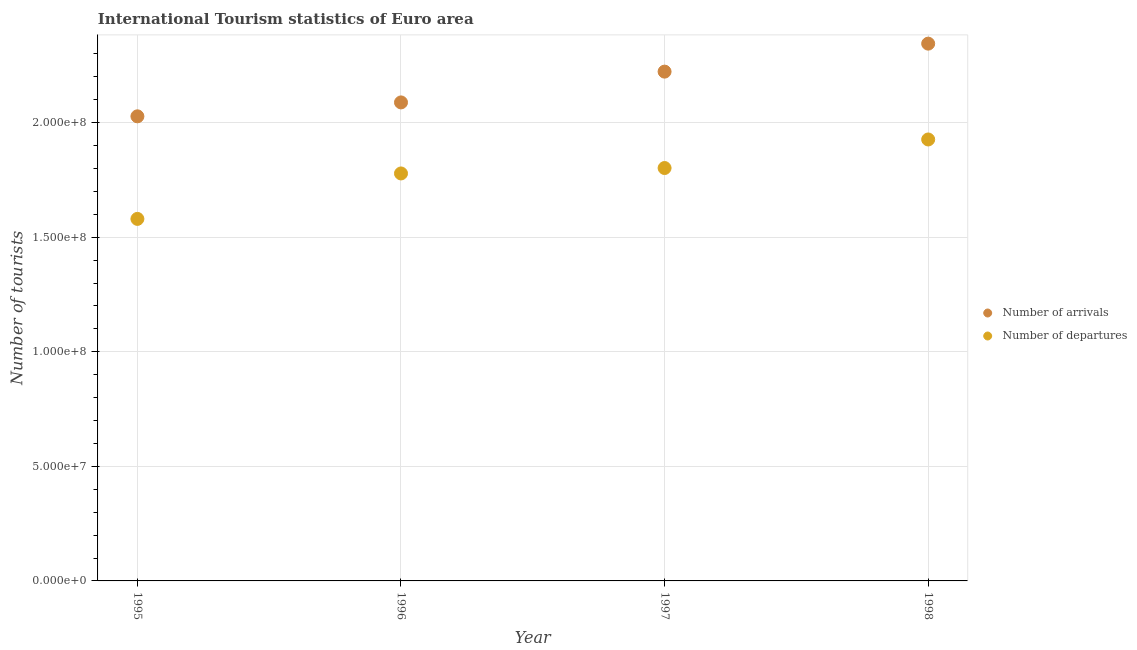How many different coloured dotlines are there?
Provide a succinct answer. 2. Is the number of dotlines equal to the number of legend labels?
Offer a terse response. Yes. What is the number of tourist departures in 1995?
Make the answer very short. 1.58e+08. Across all years, what is the maximum number of tourist departures?
Your answer should be compact. 1.93e+08. Across all years, what is the minimum number of tourist arrivals?
Your answer should be very brief. 2.03e+08. In which year was the number of tourist arrivals minimum?
Provide a succinct answer. 1995. What is the total number of tourist arrivals in the graph?
Ensure brevity in your answer.  8.68e+08. What is the difference between the number of tourist departures in 1995 and that in 1996?
Offer a very short reply. -1.98e+07. What is the difference between the number of tourist departures in 1997 and the number of tourist arrivals in 1995?
Provide a short and direct response. -2.26e+07. What is the average number of tourist arrivals per year?
Your answer should be compact. 2.17e+08. In the year 1995, what is the difference between the number of tourist arrivals and number of tourist departures?
Offer a very short reply. 4.48e+07. What is the ratio of the number of tourist arrivals in 1995 to that in 1997?
Offer a terse response. 0.91. Is the number of tourist departures in 1995 less than that in 1998?
Provide a short and direct response. Yes. Is the difference between the number of tourist arrivals in 1995 and 1998 greater than the difference between the number of tourist departures in 1995 and 1998?
Keep it short and to the point. Yes. What is the difference between the highest and the second highest number of tourist departures?
Provide a short and direct response. 1.25e+07. What is the difference between the highest and the lowest number of tourist departures?
Your answer should be compact. 3.47e+07. In how many years, is the number of tourist arrivals greater than the average number of tourist arrivals taken over all years?
Keep it short and to the point. 2. Does the number of tourist departures monotonically increase over the years?
Offer a terse response. Yes. How many dotlines are there?
Your response must be concise. 2. How many years are there in the graph?
Your response must be concise. 4. What is the difference between two consecutive major ticks on the Y-axis?
Your answer should be very brief. 5.00e+07. Are the values on the major ticks of Y-axis written in scientific E-notation?
Your answer should be very brief. Yes. Does the graph contain grids?
Offer a very short reply. Yes. What is the title of the graph?
Ensure brevity in your answer.  International Tourism statistics of Euro area. What is the label or title of the X-axis?
Your response must be concise. Year. What is the label or title of the Y-axis?
Provide a short and direct response. Number of tourists. What is the Number of tourists of Number of arrivals in 1995?
Offer a very short reply. 2.03e+08. What is the Number of tourists in Number of departures in 1995?
Your answer should be very brief. 1.58e+08. What is the Number of tourists in Number of arrivals in 1996?
Make the answer very short. 2.09e+08. What is the Number of tourists in Number of departures in 1996?
Make the answer very short. 1.78e+08. What is the Number of tourists in Number of arrivals in 1997?
Give a very brief answer. 2.22e+08. What is the Number of tourists in Number of departures in 1997?
Keep it short and to the point. 1.80e+08. What is the Number of tourists of Number of arrivals in 1998?
Give a very brief answer. 2.34e+08. What is the Number of tourists of Number of departures in 1998?
Your response must be concise. 1.93e+08. Across all years, what is the maximum Number of tourists in Number of arrivals?
Offer a very short reply. 2.34e+08. Across all years, what is the maximum Number of tourists of Number of departures?
Your answer should be very brief. 1.93e+08. Across all years, what is the minimum Number of tourists in Number of arrivals?
Ensure brevity in your answer.  2.03e+08. Across all years, what is the minimum Number of tourists in Number of departures?
Keep it short and to the point. 1.58e+08. What is the total Number of tourists in Number of arrivals in the graph?
Make the answer very short. 8.68e+08. What is the total Number of tourists in Number of departures in the graph?
Offer a very short reply. 7.09e+08. What is the difference between the Number of tourists in Number of arrivals in 1995 and that in 1996?
Give a very brief answer. -6.07e+06. What is the difference between the Number of tourists of Number of departures in 1995 and that in 1996?
Provide a short and direct response. -1.98e+07. What is the difference between the Number of tourists in Number of arrivals in 1995 and that in 1997?
Give a very brief answer. -1.95e+07. What is the difference between the Number of tourists of Number of departures in 1995 and that in 1997?
Make the answer very short. -2.22e+07. What is the difference between the Number of tourists of Number of arrivals in 1995 and that in 1998?
Offer a very short reply. -3.17e+07. What is the difference between the Number of tourists in Number of departures in 1995 and that in 1998?
Make the answer very short. -3.47e+07. What is the difference between the Number of tourists of Number of arrivals in 1996 and that in 1997?
Offer a terse response. -1.34e+07. What is the difference between the Number of tourists of Number of departures in 1996 and that in 1997?
Give a very brief answer. -2.37e+06. What is the difference between the Number of tourists in Number of arrivals in 1996 and that in 1998?
Keep it short and to the point. -2.56e+07. What is the difference between the Number of tourists in Number of departures in 1996 and that in 1998?
Offer a very short reply. -1.48e+07. What is the difference between the Number of tourists in Number of arrivals in 1997 and that in 1998?
Your response must be concise. -1.22e+07. What is the difference between the Number of tourists in Number of departures in 1997 and that in 1998?
Give a very brief answer. -1.25e+07. What is the difference between the Number of tourists of Number of arrivals in 1995 and the Number of tourists of Number of departures in 1996?
Offer a very short reply. 2.49e+07. What is the difference between the Number of tourists of Number of arrivals in 1995 and the Number of tourists of Number of departures in 1997?
Your answer should be very brief. 2.26e+07. What is the difference between the Number of tourists of Number of arrivals in 1995 and the Number of tourists of Number of departures in 1998?
Your answer should be compact. 1.01e+07. What is the difference between the Number of tourists of Number of arrivals in 1996 and the Number of tourists of Number of departures in 1997?
Your answer should be very brief. 2.86e+07. What is the difference between the Number of tourists in Number of arrivals in 1996 and the Number of tourists in Number of departures in 1998?
Ensure brevity in your answer.  1.62e+07. What is the difference between the Number of tourists in Number of arrivals in 1997 and the Number of tourists in Number of departures in 1998?
Your response must be concise. 2.96e+07. What is the average Number of tourists of Number of arrivals per year?
Your response must be concise. 2.17e+08. What is the average Number of tourists of Number of departures per year?
Provide a short and direct response. 1.77e+08. In the year 1995, what is the difference between the Number of tourists in Number of arrivals and Number of tourists in Number of departures?
Your answer should be compact. 4.48e+07. In the year 1996, what is the difference between the Number of tourists in Number of arrivals and Number of tourists in Number of departures?
Offer a terse response. 3.10e+07. In the year 1997, what is the difference between the Number of tourists in Number of arrivals and Number of tourists in Number of departures?
Offer a very short reply. 4.21e+07. In the year 1998, what is the difference between the Number of tourists of Number of arrivals and Number of tourists of Number of departures?
Ensure brevity in your answer.  4.18e+07. What is the ratio of the Number of tourists in Number of arrivals in 1995 to that in 1996?
Offer a very short reply. 0.97. What is the ratio of the Number of tourists in Number of departures in 1995 to that in 1996?
Offer a terse response. 0.89. What is the ratio of the Number of tourists of Number of arrivals in 1995 to that in 1997?
Your answer should be very brief. 0.91. What is the ratio of the Number of tourists in Number of departures in 1995 to that in 1997?
Keep it short and to the point. 0.88. What is the ratio of the Number of tourists in Number of arrivals in 1995 to that in 1998?
Ensure brevity in your answer.  0.86. What is the ratio of the Number of tourists in Number of departures in 1995 to that in 1998?
Offer a very short reply. 0.82. What is the ratio of the Number of tourists of Number of arrivals in 1996 to that in 1997?
Ensure brevity in your answer.  0.94. What is the ratio of the Number of tourists of Number of arrivals in 1996 to that in 1998?
Keep it short and to the point. 0.89. What is the ratio of the Number of tourists in Number of departures in 1996 to that in 1998?
Offer a terse response. 0.92. What is the ratio of the Number of tourists in Number of arrivals in 1997 to that in 1998?
Make the answer very short. 0.95. What is the ratio of the Number of tourists of Number of departures in 1997 to that in 1998?
Your answer should be compact. 0.94. What is the difference between the highest and the second highest Number of tourists of Number of arrivals?
Keep it short and to the point. 1.22e+07. What is the difference between the highest and the second highest Number of tourists of Number of departures?
Your answer should be compact. 1.25e+07. What is the difference between the highest and the lowest Number of tourists of Number of arrivals?
Make the answer very short. 3.17e+07. What is the difference between the highest and the lowest Number of tourists in Number of departures?
Keep it short and to the point. 3.47e+07. 